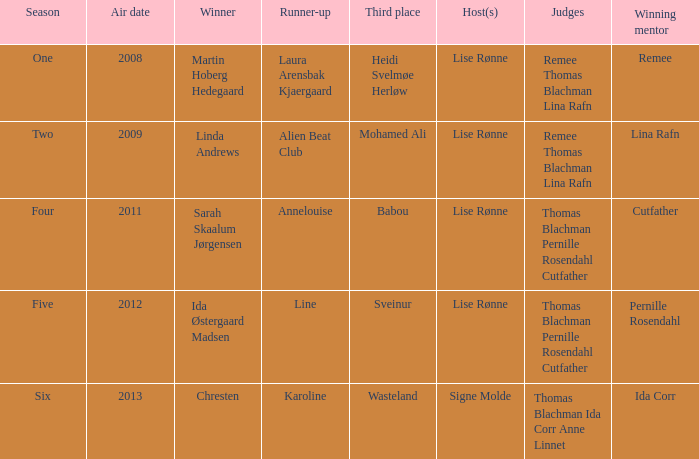Who achieved third place in season four? Babou. 